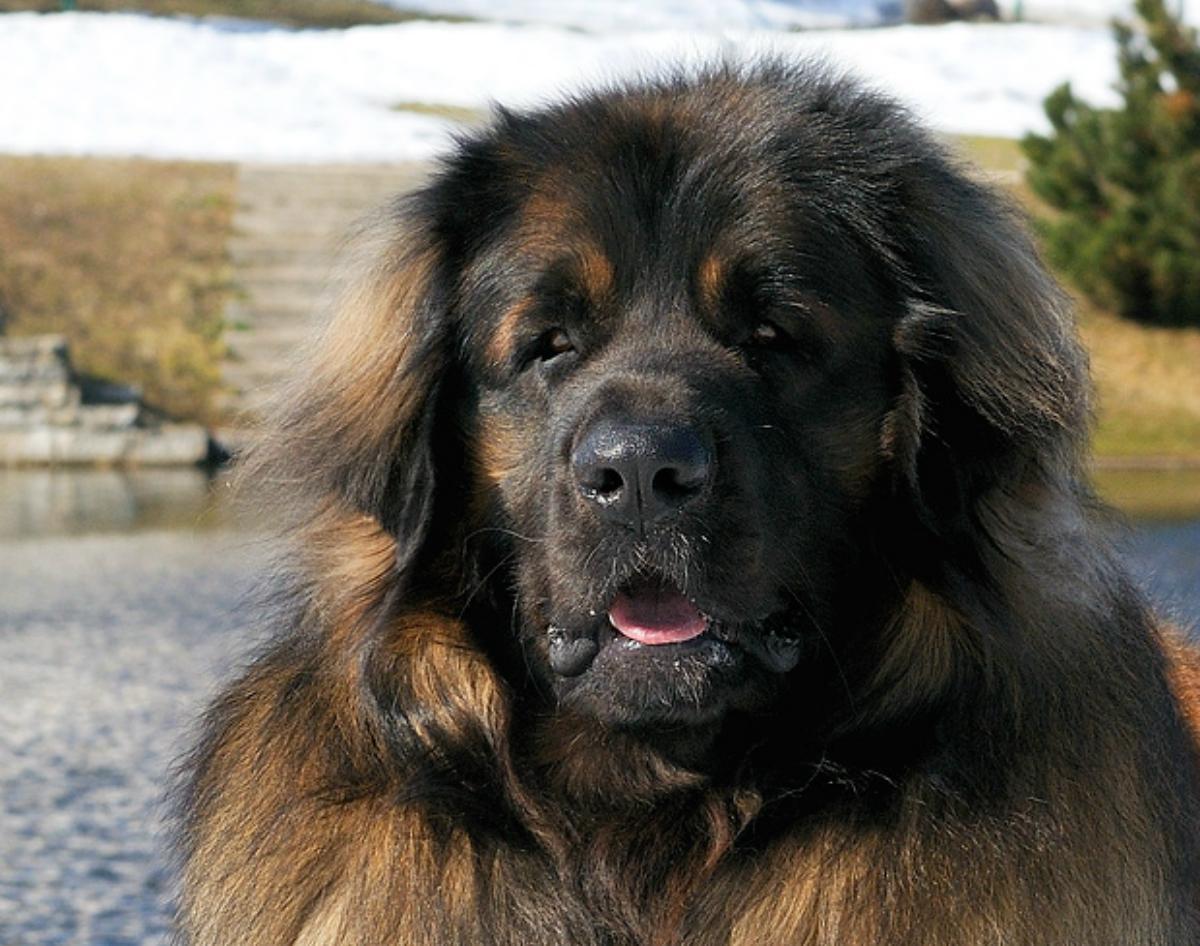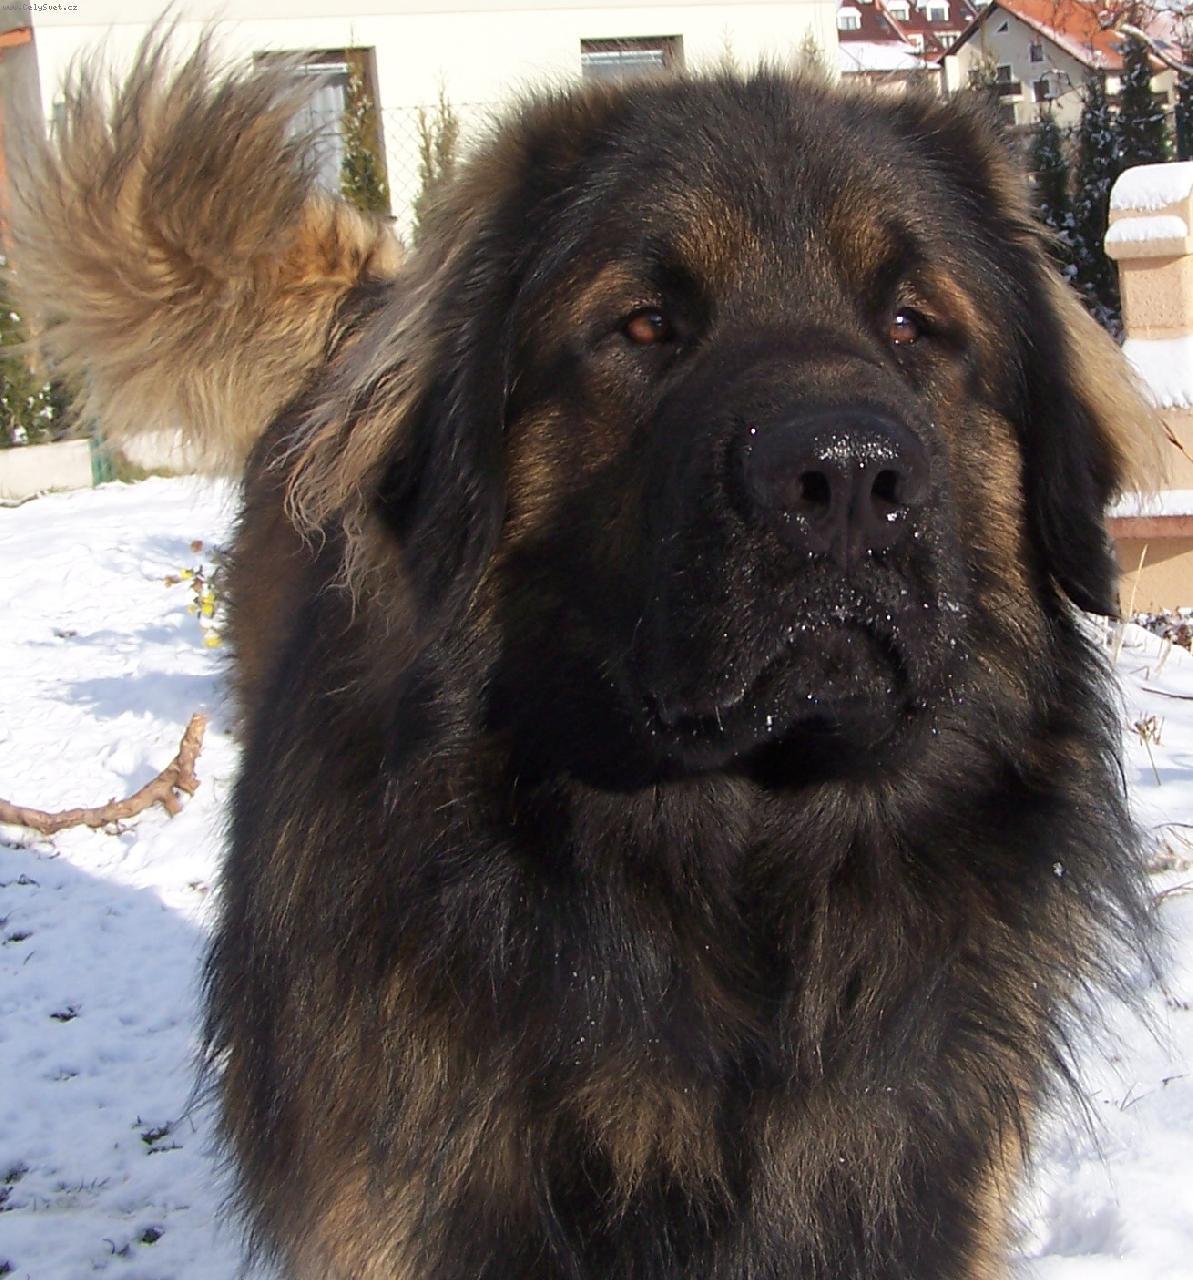The first image is the image on the left, the second image is the image on the right. Assess this claim about the two images: "The dog's legs are not visible in any of the images.". Correct or not? Answer yes or no. Yes. The first image is the image on the left, the second image is the image on the right. Given the left and right images, does the statement "The dog in the right image is panting with its tongue hanging out." hold true? Answer yes or no. No. 